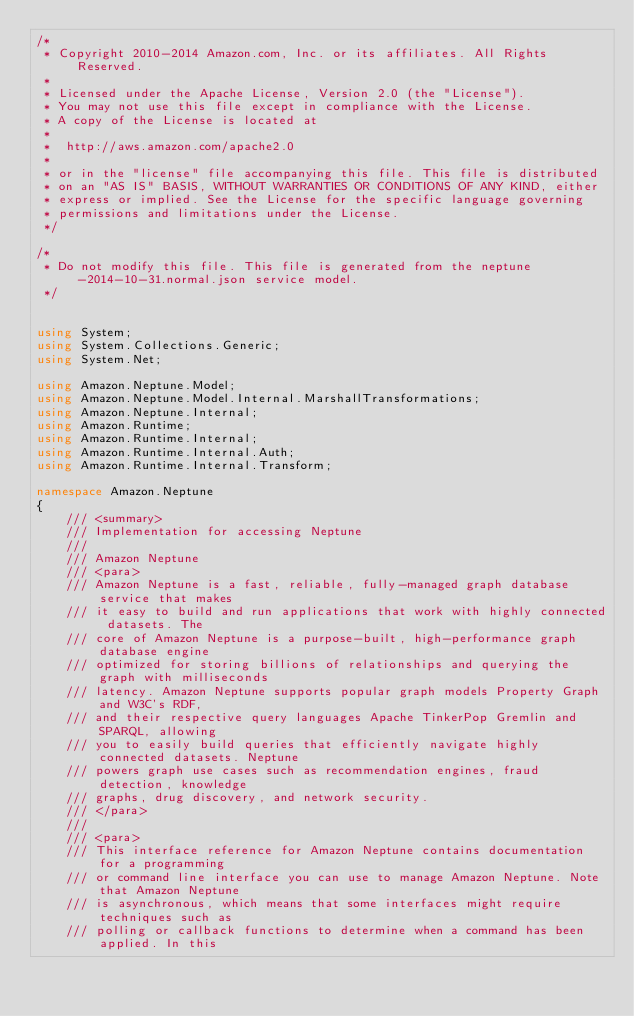Convert code to text. <code><loc_0><loc_0><loc_500><loc_500><_C#_>/*
 * Copyright 2010-2014 Amazon.com, Inc. or its affiliates. All Rights Reserved.
 * 
 * Licensed under the Apache License, Version 2.0 (the "License").
 * You may not use this file except in compliance with the License.
 * A copy of the License is located at
 * 
 *  http://aws.amazon.com/apache2.0
 * 
 * or in the "license" file accompanying this file. This file is distributed
 * on an "AS IS" BASIS, WITHOUT WARRANTIES OR CONDITIONS OF ANY KIND, either
 * express or implied. See the License for the specific language governing
 * permissions and limitations under the License.
 */

/*
 * Do not modify this file. This file is generated from the neptune-2014-10-31.normal.json service model.
 */


using System;
using System.Collections.Generic;
using System.Net;

using Amazon.Neptune.Model;
using Amazon.Neptune.Model.Internal.MarshallTransformations;
using Amazon.Neptune.Internal;
using Amazon.Runtime;
using Amazon.Runtime.Internal;
using Amazon.Runtime.Internal.Auth;
using Amazon.Runtime.Internal.Transform;

namespace Amazon.Neptune
{
    /// <summary>
    /// Implementation for accessing Neptune
    ///
    /// Amazon Neptune 
    /// <para>
    /// Amazon Neptune is a fast, reliable, fully-managed graph database service that makes
    /// it easy to build and run applications that work with highly connected datasets. The
    /// core of Amazon Neptune is a purpose-built, high-performance graph database engine
    /// optimized for storing billions of relationships and querying the graph with milliseconds
    /// latency. Amazon Neptune supports popular graph models Property Graph and W3C's RDF,
    /// and their respective query languages Apache TinkerPop Gremlin and SPARQL, allowing
    /// you to easily build queries that efficiently navigate highly connected datasets. Neptune
    /// powers graph use cases such as recommendation engines, fraud detection, knowledge
    /// graphs, drug discovery, and network security.
    /// </para>
    ///  
    /// <para>
    /// This interface reference for Amazon Neptune contains documentation for a programming
    /// or command line interface you can use to manage Amazon Neptune. Note that Amazon Neptune
    /// is asynchronous, which means that some interfaces might require techniques such as
    /// polling or callback functions to determine when a command has been applied. In this</code> 